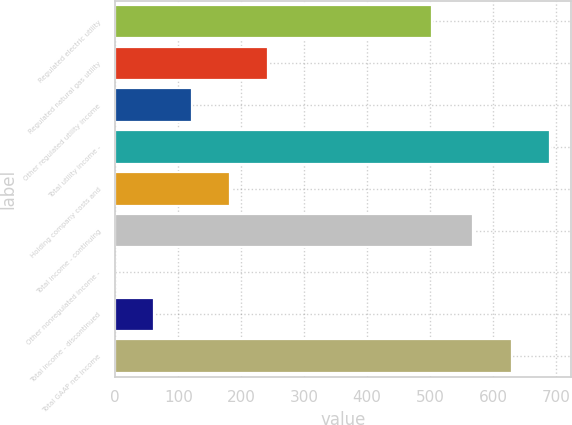Convert chart. <chart><loc_0><loc_0><loc_500><loc_500><bar_chart><fcel>Regulated electric utility<fcel>Regulated natural gas utility<fcel>Other regulated utility income<fcel>Total utility income -<fcel>Holding company costs and<fcel>Total income - continuing<fcel>Other nonregulated income -<fcel>Total income - discontinued<fcel>Total GAAP net income<nl><fcel>503.1<fcel>242.46<fcel>121.28<fcel>689.88<fcel>181.87<fcel>568.7<fcel>0.1<fcel>60.69<fcel>629.29<nl></chart> 